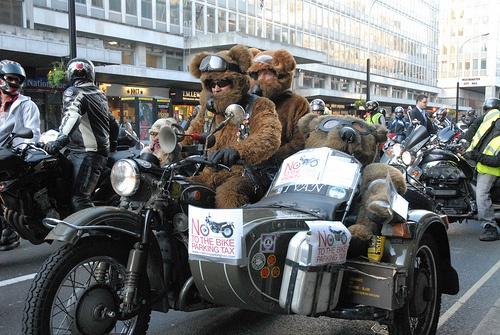Describe the objects in this image and their specific colors. I can see motorcycle in gray, black, white, and darkgray tones, people in gray, black, and maroon tones, motorcycle in gray, black, and darkgray tones, people in gray, black, darkgray, and lightgray tones, and motorcycle in gray, black, darkgray, and white tones in this image. 